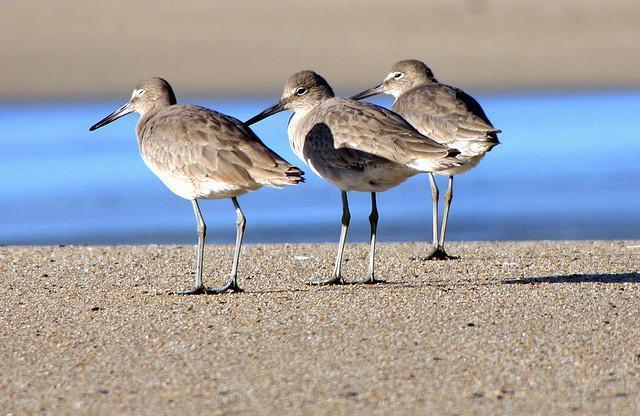How many birds are there?
Give a very brief answer. 3. 